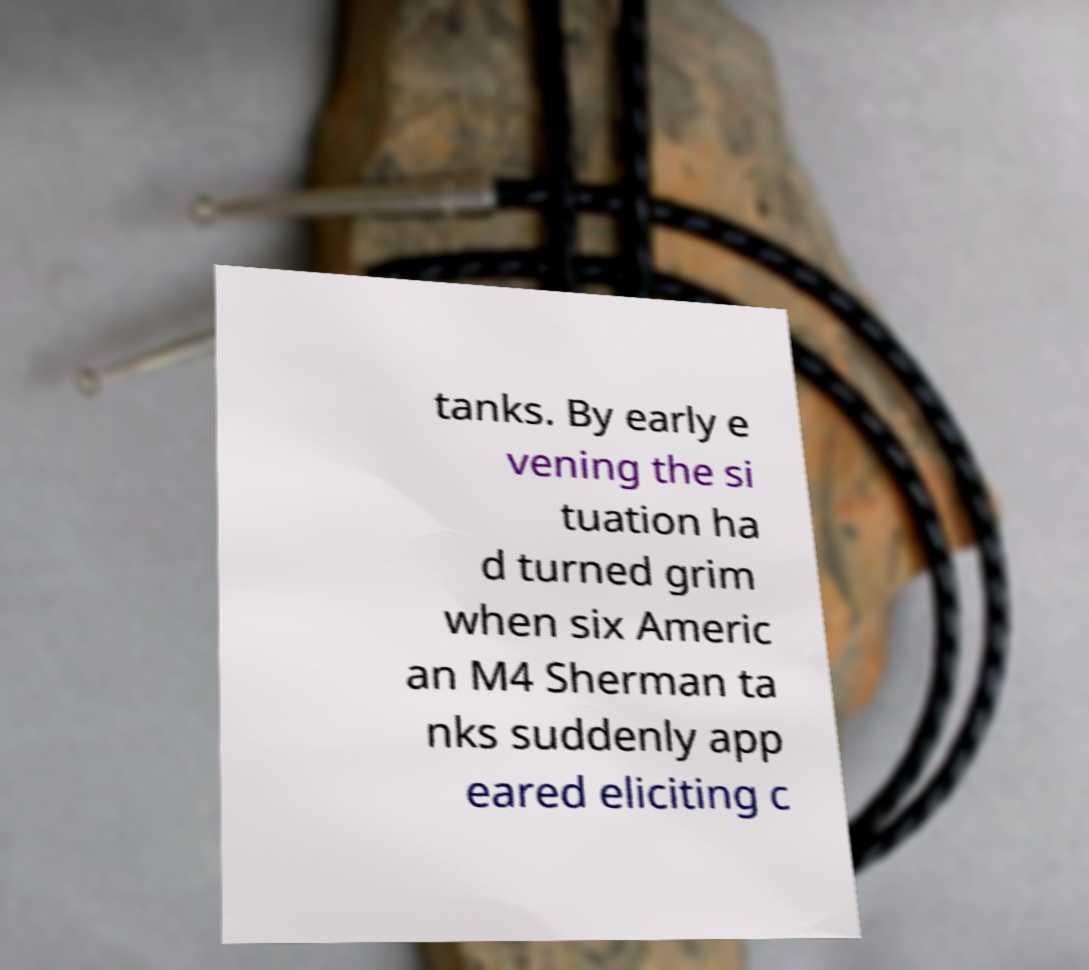Can you read and provide the text displayed in the image?This photo seems to have some interesting text. Can you extract and type it out for me? tanks. By early e vening the si tuation ha d turned grim when six Americ an M4 Sherman ta nks suddenly app eared eliciting c 